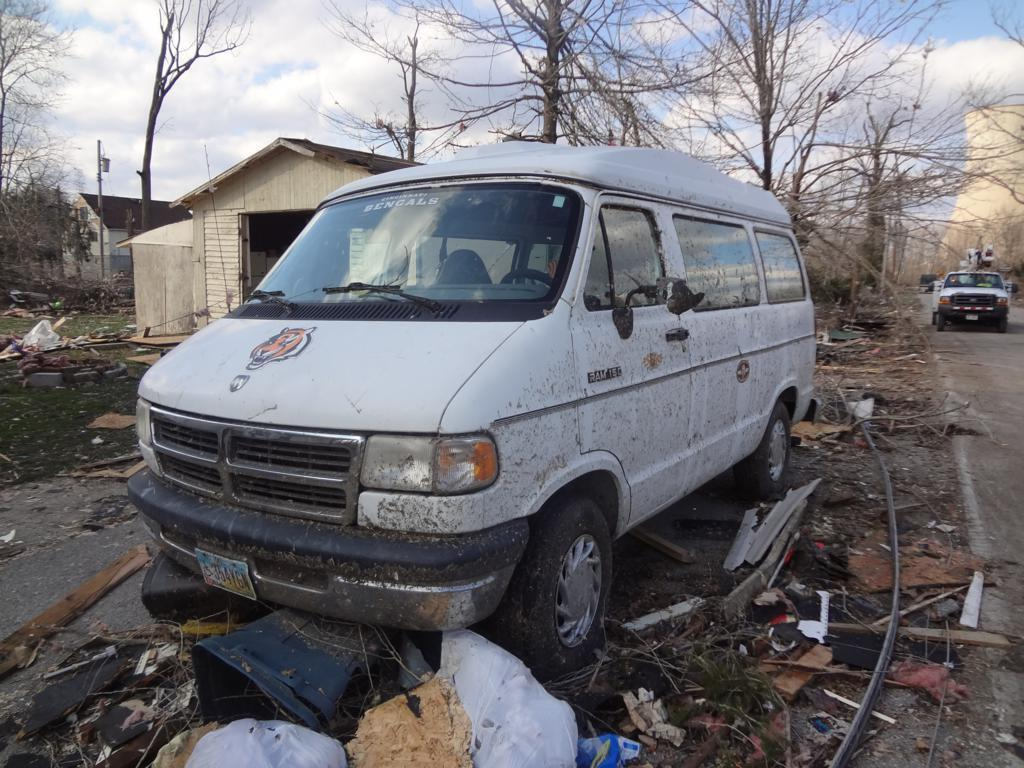Provide a one-sentence caption for the provided image. A dirty Ram 150 van with a Bengals sign in the windshield. 